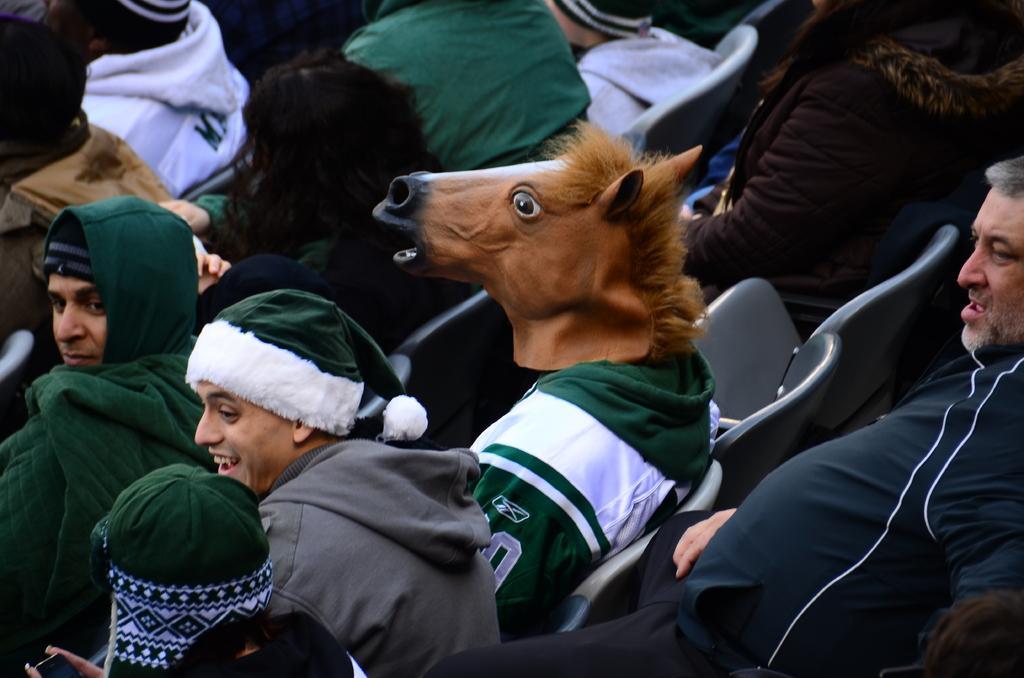Can you describe this image briefly? In the image we can see there are people sitting, they are wearing clothes and some of them are wearing cap. Here we can see a person wearing the animal mask and there are many chairs. 